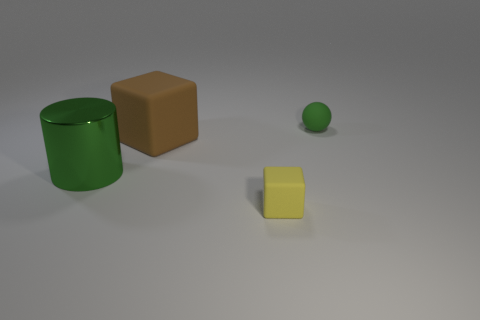Are there any other things that have the same material as the big green cylinder?
Give a very brief answer. No. There is a green metallic cylinder that is in front of the brown object; what size is it?
Provide a succinct answer. Large. Are there an equal number of small yellow blocks on the right side of the tiny green thing and green matte things?
Give a very brief answer. No. Is there a green matte object of the same shape as the yellow rubber thing?
Make the answer very short. No. What is the shape of the matte object that is both in front of the ball and behind the yellow thing?
Your response must be concise. Cube. Are the large green thing and the cube that is right of the large brown matte cube made of the same material?
Your answer should be very brief. No. There is a green sphere; are there any small green things in front of it?
Your response must be concise. No. How many things are small yellow things or things behind the large green metallic cylinder?
Your response must be concise. 3. There is a small rubber thing that is in front of the rubber object that is right of the small block; what is its color?
Ensure brevity in your answer.  Yellow. How many other objects are there of the same material as the large brown thing?
Your answer should be very brief. 2. 